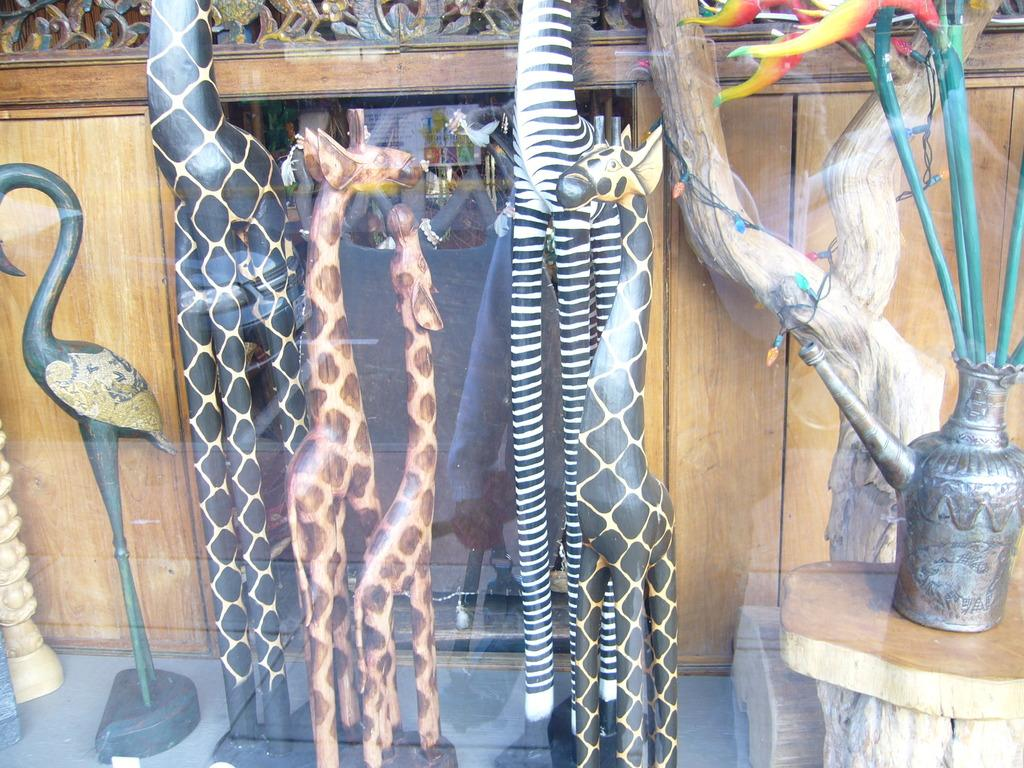What type of objects are featured in the image? There are crafts in the image. What can be seen in the background of the image? There is a wooden wall in the background of the image. How does the stomach of the craft feel in the image? There is no mention of a stomach or any living organisms in the image, as it features crafts and a wooden wall. 